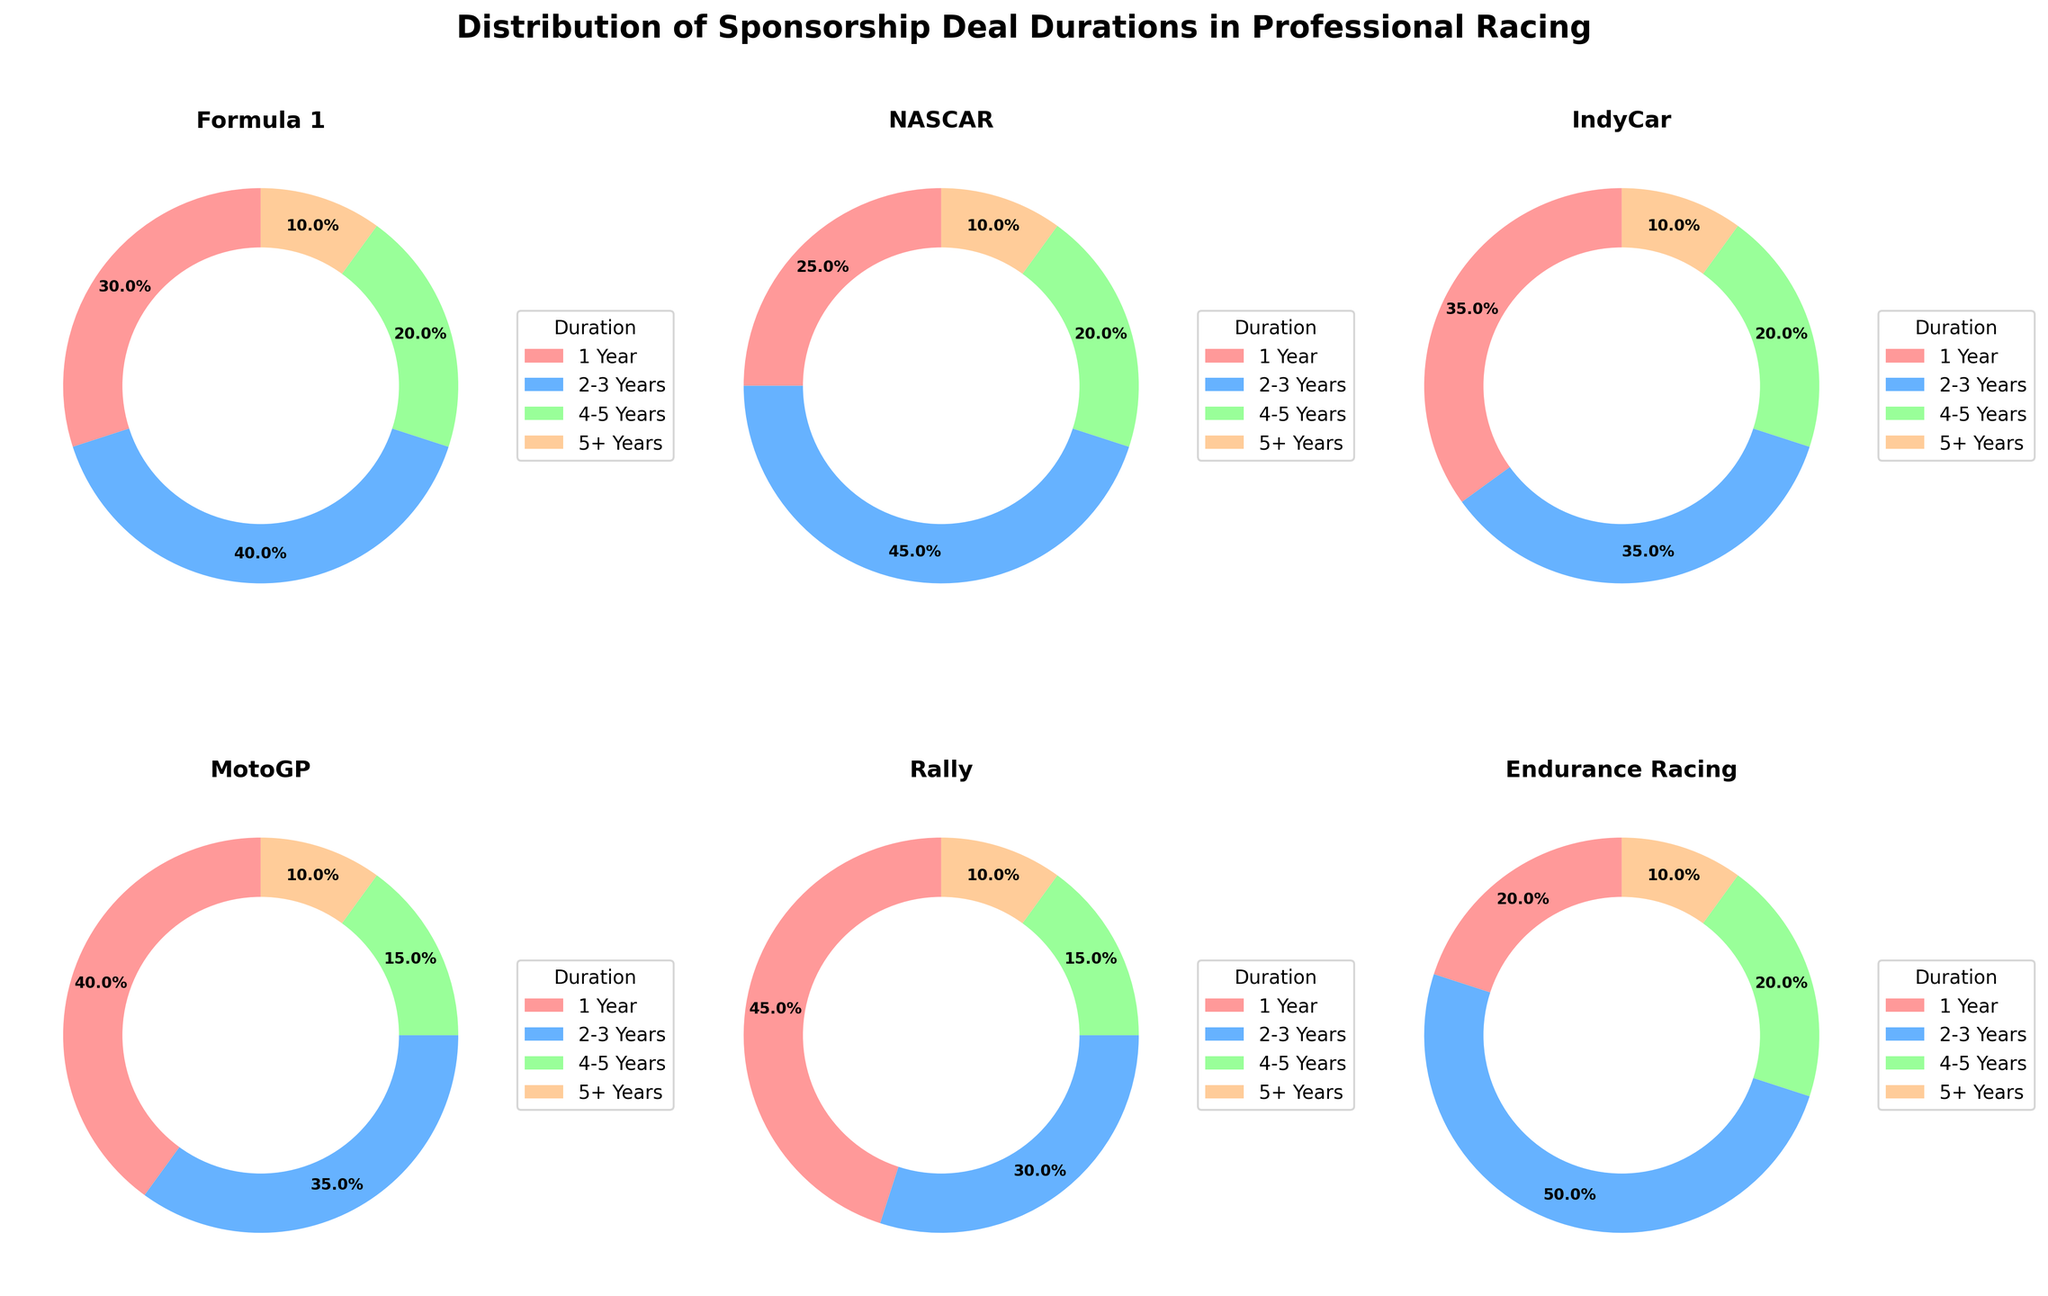What categories are compared in the figure? The figure has subplots for six different categories in professional racing. They include 'Formula 1', 'NASCAR', 'IndyCar', 'MotoGP', 'Rally', and 'Endurance Racing'.
Answer: Six categories: 'Formula 1', 'NASCAR', 'IndyCar', 'MotoGP', 'Rally', 'Endurance Racing' Which category has the highest percentage of 1-year sponsorship deals? The 1-year sponsorship deals percentage can be directly read from the pie charts. 'Rally' has the highest with 45%.
Answer: Rally with 45% How does the distribution of 2-3 year deals in Formula 1 compare to that in NASCAR? The pie charts show that Formula 1 has 40% of its deals lasting 2-3 years, while NASCAR has a slightly higher percentage of 45%.
Answer: NASCAR is 5% higher Which category shows an equal percentage of 1-year and 4-5 year deals? By examining the pie charts, 'IndyCar' shows an equal percentage of 35% for both 1-year and 4-5 year deals.
Answer: IndyCar with 35% each What is the common percentage for 5+ year deals across all categories? All categories have a consistent percentage of 10% for 5+ year deals, as shown in each pie chart.
Answer: 10% Which category has the most balanced distribution of sponsorship durations? Based on the pie charts, 'Endurance Racing' has the most balanced distribution with percentages of 20% (1 year), 50% (2-3 years), 20% (4-5 years), and 10% (5+ years).
Answer: Endurance Racing How many categories have more than 30% of their deals lasting 1 year? By reviewing the pie charts, the categories with more than 30% 1-year deals are Formula 1, IndyCar, MotoGP, and Rally, totaling four categories.
Answer: Four categories Which category has the highest percentage of 4-5 year deals and what is the percentage? The pie charts show that 'Formula 1', 'NASCAR', 'IndyCar', 'MotoGP', 'Rally', and 'Endurance Racing' all have 20% of their deals lasting 4-5 years. However, none has a higher than 20%.
Answer: None, all are 20% What's the total combined percentage of 1-year deals across all categories? Summing up the percentage of 1-year deals: Formula 1 (30%) + NASCAR (25%) + IndyCar (35%) + MotoGP (40%) + Rally (45%) + Endurance Racing (20%) equals 195%. Divided by the number of categories (6) gives an average percentage.
Answer: 195% Which category has the lowest percentage of 2-3 year deals? From the pie charts, 'Rally' has the lowest percentage of 2-3 year deals with 30%.
Answer: Rally with 30% 